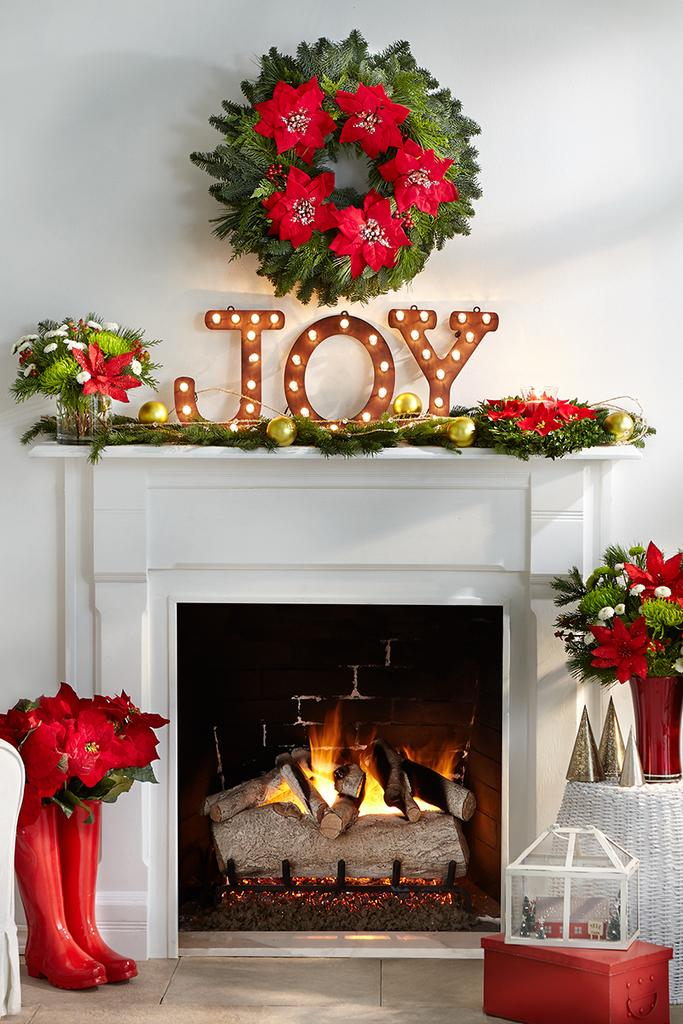What is the main feature in the image? There is a fireplace in the image. What other objects can be seen in the image? There are flower vases, boxes, alphabets with lights, and decor items in the image. What type of surface is at the bottom of the image? There is a floor at the bottom of the image. What type of fruit is being touched by the alphabets with lights in the image? There is no fruit present in the image, and the alphabets with lights are not touching any fruit. 